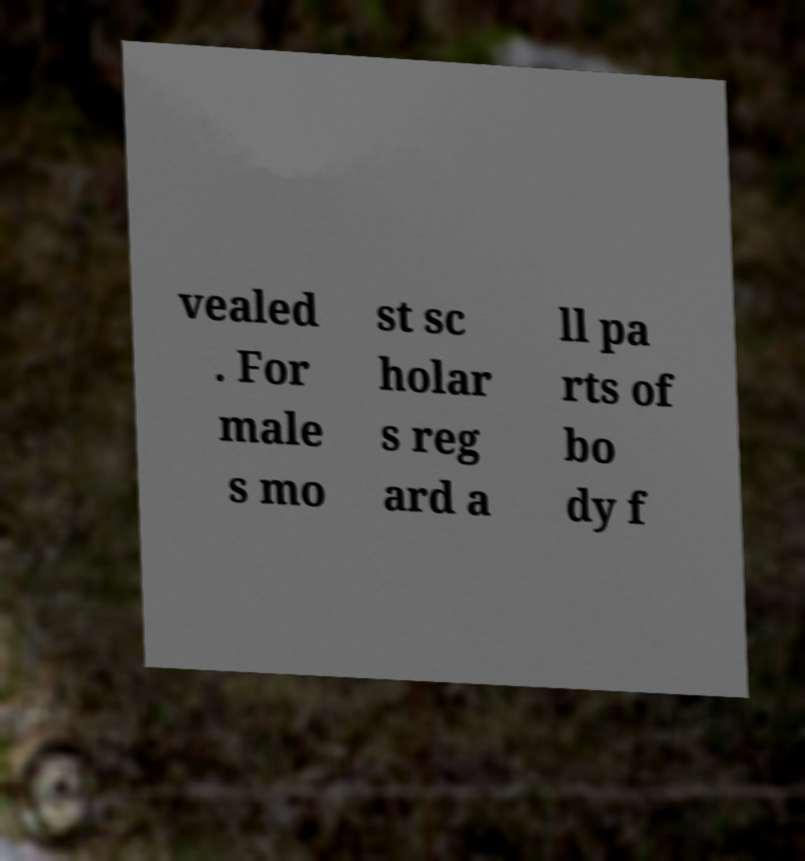Can you accurately transcribe the text from the provided image for me? vealed . For male s mo st sc holar s reg ard a ll pa rts of bo dy f 